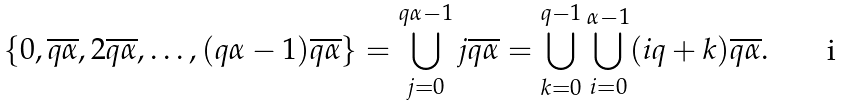Convert formula to latex. <formula><loc_0><loc_0><loc_500><loc_500>\{ 0 , \overline { q \alpha } , 2 \overline { q \alpha } , \dots , ( q \alpha - 1 ) \overline { q \alpha } \} = \bigcup _ { j = 0 } ^ { q \alpha - 1 } j \overline { q \alpha } = \bigcup _ { k = 0 } ^ { q - 1 } \bigcup _ { i = 0 } ^ { \alpha - 1 } ( i q + k ) \overline { q \alpha } .</formula> 